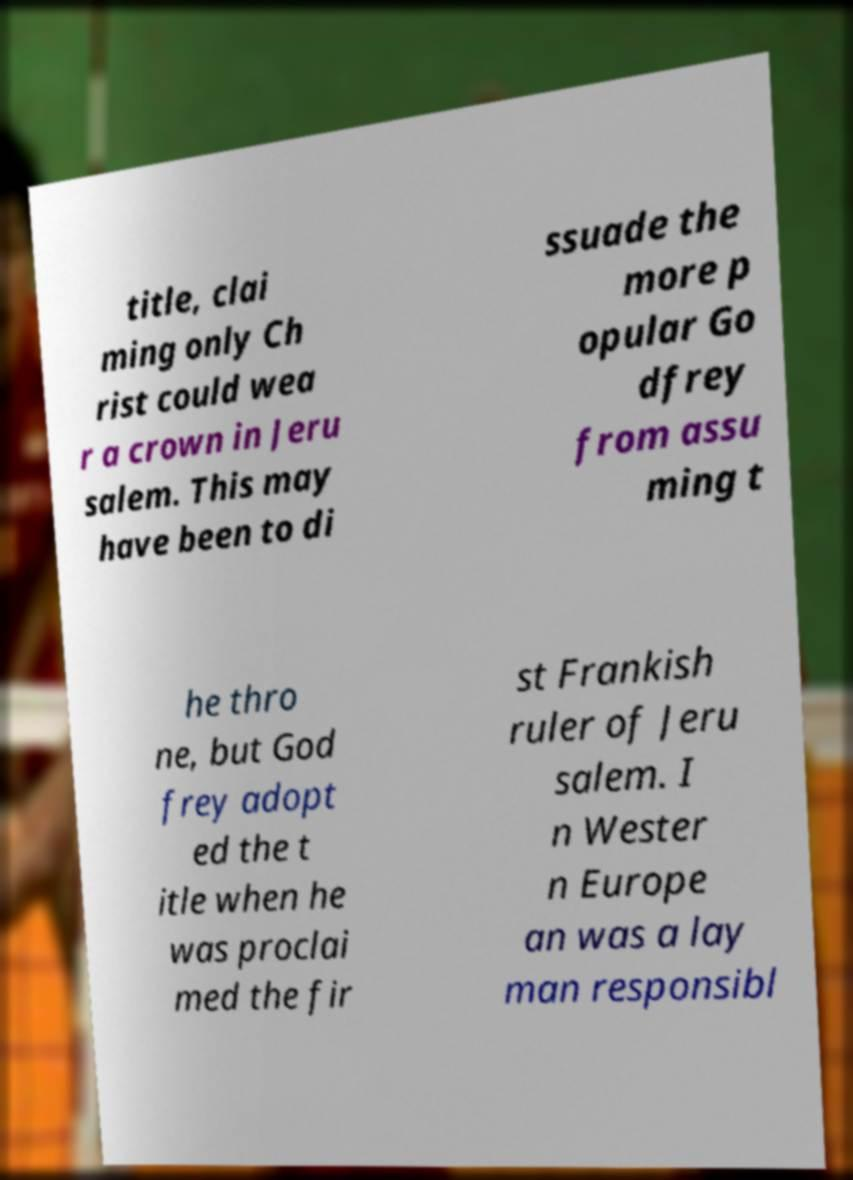Please read and relay the text visible in this image. What does it say? title, clai ming only Ch rist could wea r a crown in Jeru salem. This may have been to di ssuade the more p opular Go dfrey from assu ming t he thro ne, but God frey adopt ed the t itle when he was proclai med the fir st Frankish ruler of Jeru salem. I n Wester n Europe an was a lay man responsibl 